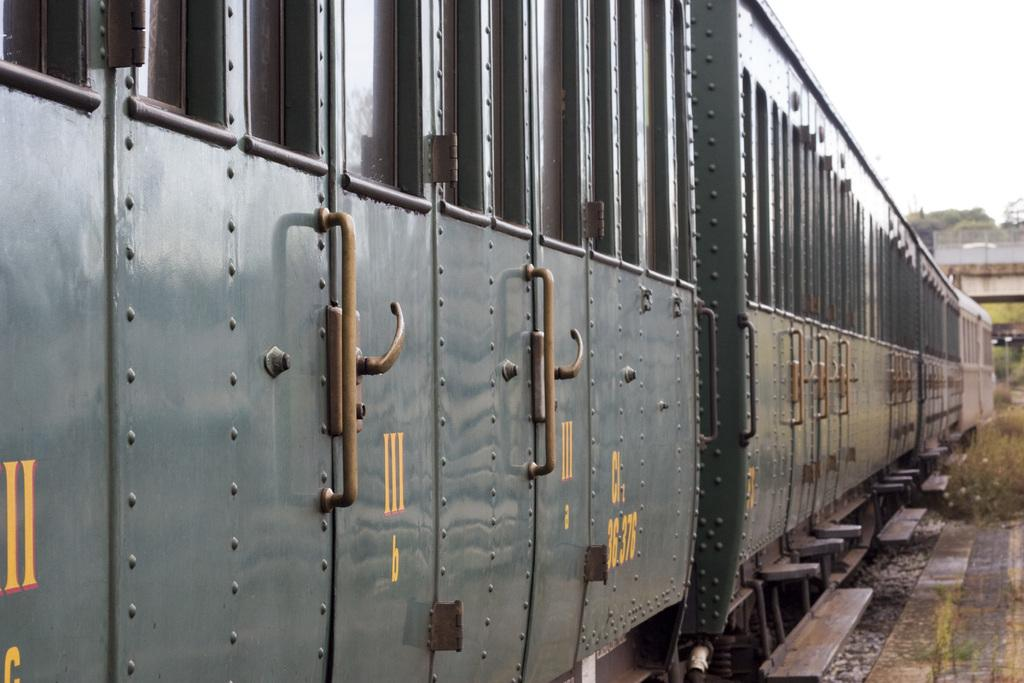What is the main subject of the image? There is a train in the image. What can be seen on the right side of the image? There are plants and trees on the right side of the image. Can you tell me how many levels are visible in the train in the image? There is no indication of multiple levels in the train in the image; it appears to be a single-level train. Is there a nest visible in the image? There is no nest present in the image. 